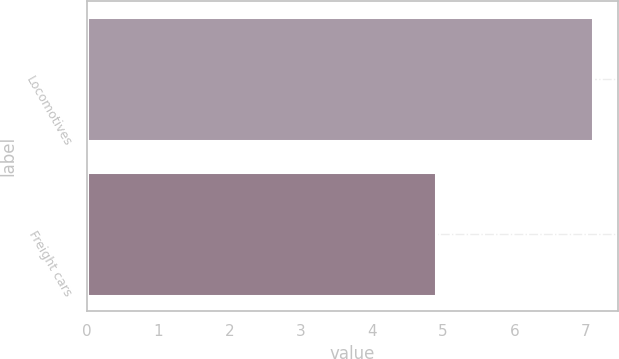Convert chart. <chart><loc_0><loc_0><loc_500><loc_500><bar_chart><fcel>Locomotives<fcel>Freight cars<nl><fcel>7.1<fcel>4.9<nl></chart> 